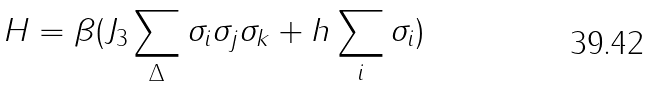<formula> <loc_0><loc_0><loc_500><loc_500>H = \beta ( J _ { 3 } \sum _ { \Delta } \sigma _ { i } \sigma _ { j } \sigma _ { k } + h \sum _ { i } \sigma _ { i } )</formula> 